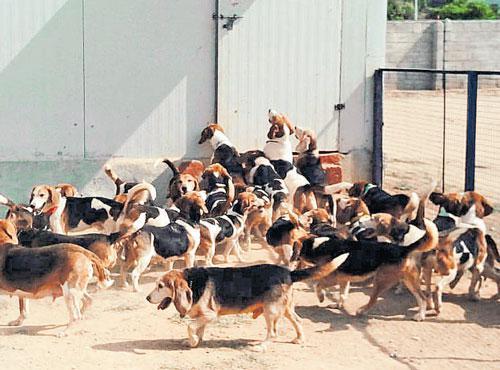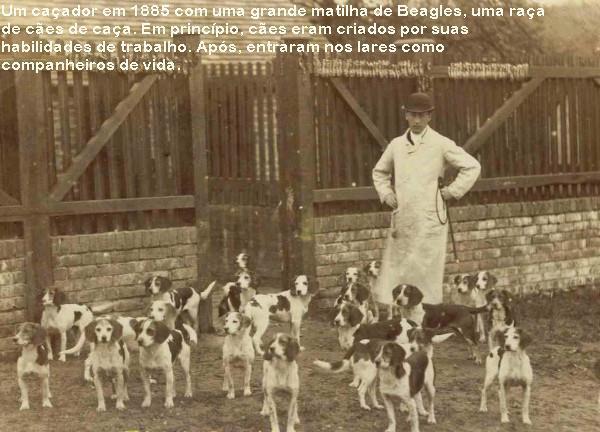The first image is the image on the left, the second image is the image on the right. Evaluate the accuracy of this statement regarding the images: "In one image, fox hunters are on horses with a pack of hounds.". Is it true? Answer yes or no. No. 